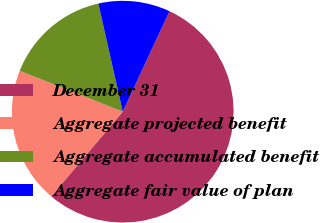Convert chart to OTSL. <chart><loc_0><loc_0><loc_500><loc_500><pie_chart><fcel>December 31<fcel>Aggregate projected benefit<fcel>Aggregate accumulated benefit<fcel>Aggregate fair value of plan<nl><fcel>54.23%<fcel>19.84%<fcel>15.46%<fcel>10.47%<nl></chart> 